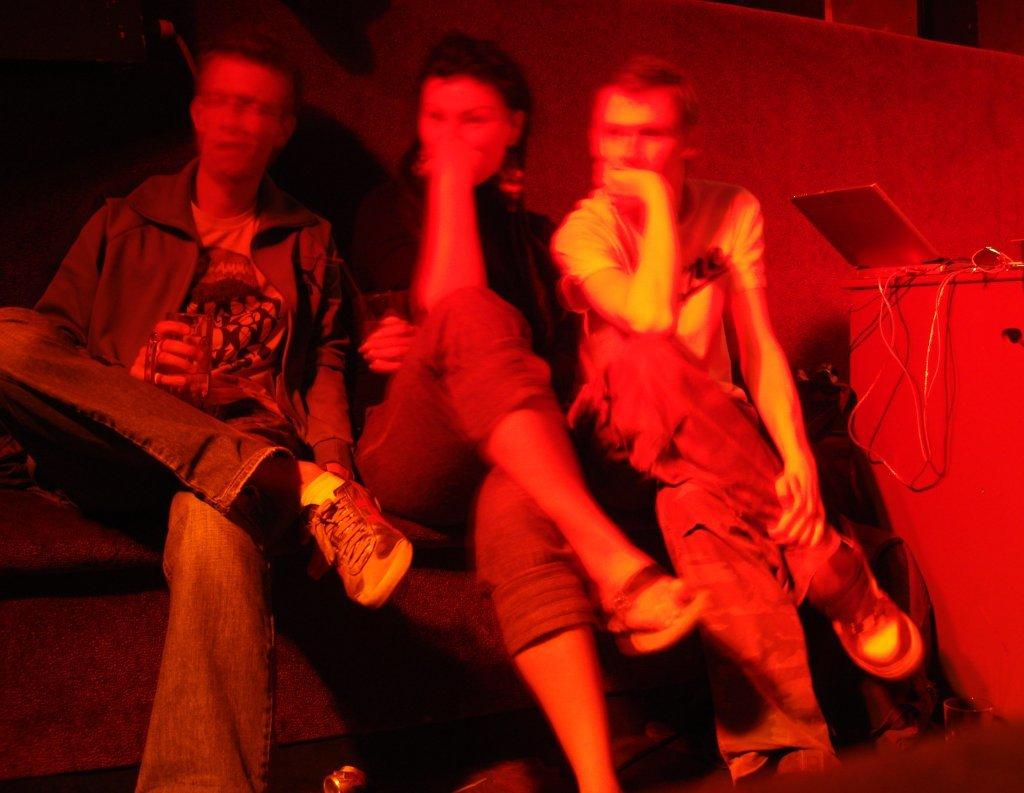How many people are sitting in the image? There are three people sitting in the image. Can you describe the objects on the table in the image? There is a laptop on the right side of the table in the image. What type of mine can be seen in the image? There is no mine present in the image. What is the glue used for in the image? There is no glue present in the image. 